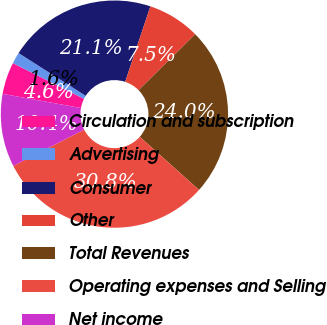Convert chart to OTSL. <chart><loc_0><loc_0><loc_500><loc_500><pie_chart><fcel>Circulation and subscription<fcel>Advertising<fcel>Consumer<fcel>Other<fcel>Total Revenues<fcel>Operating expenses and Selling<fcel>Net income<nl><fcel>4.55%<fcel>1.62%<fcel>21.1%<fcel>7.47%<fcel>24.03%<fcel>30.84%<fcel>10.39%<nl></chart> 